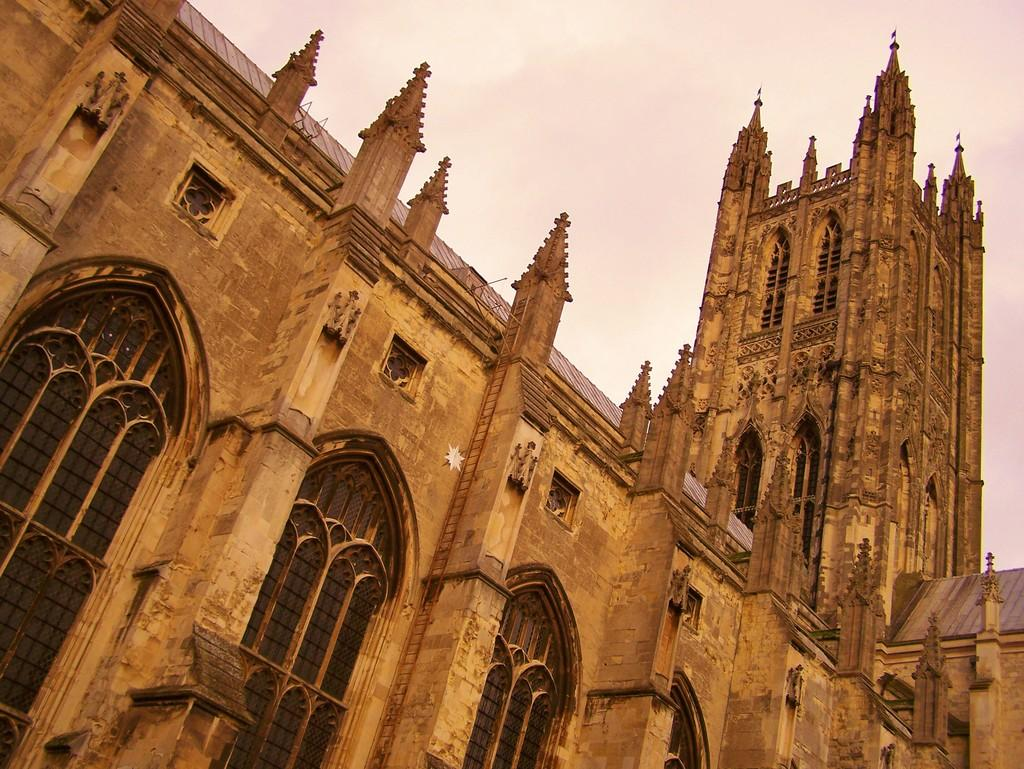What type of structures can be seen in the image? There are buildings in the image. What part of the natural environment is visible in the image? The sky is visible in the image. What can be observed in the sky? Clouds are present in the sky. What type of finger can be seen in the image? There is no finger present in the image. What type of fuel is being used by the clouds in the image? Clouds do not use fuel, and there is no indication of any fuel source in the image. 